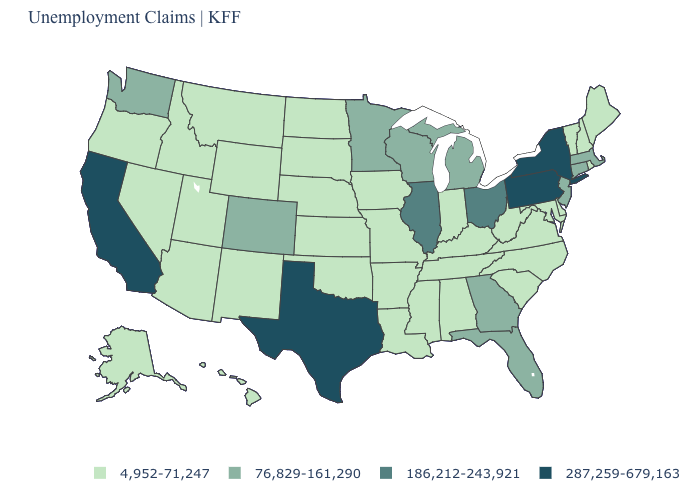What is the value of Missouri?
Keep it brief. 4,952-71,247. What is the value of Utah?
Short answer required. 4,952-71,247. What is the value of Ohio?
Give a very brief answer. 186,212-243,921. Name the states that have a value in the range 4,952-71,247?
Be succinct. Alabama, Alaska, Arizona, Arkansas, Delaware, Hawaii, Idaho, Indiana, Iowa, Kansas, Kentucky, Louisiana, Maine, Maryland, Mississippi, Missouri, Montana, Nebraska, Nevada, New Hampshire, New Mexico, North Carolina, North Dakota, Oklahoma, Oregon, Rhode Island, South Carolina, South Dakota, Tennessee, Utah, Vermont, Virginia, West Virginia, Wyoming. Does Illinois have the lowest value in the MidWest?
Quick response, please. No. Name the states that have a value in the range 287,259-679,163?
Short answer required. California, New York, Pennsylvania, Texas. Name the states that have a value in the range 76,829-161,290?
Concise answer only. Colorado, Connecticut, Florida, Georgia, Massachusetts, Michigan, Minnesota, New Jersey, Washington, Wisconsin. Is the legend a continuous bar?
Be succinct. No. Name the states that have a value in the range 76,829-161,290?
Quick response, please. Colorado, Connecticut, Florida, Georgia, Massachusetts, Michigan, Minnesota, New Jersey, Washington, Wisconsin. Which states have the lowest value in the West?
Concise answer only. Alaska, Arizona, Hawaii, Idaho, Montana, Nevada, New Mexico, Oregon, Utah, Wyoming. Does the first symbol in the legend represent the smallest category?
Give a very brief answer. Yes. Does Michigan have the lowest value in the USA?
Quick response, please. No. What is the value of Indiana?
Short answer required. 4,952-71,247. Among the states that border Tennessee , does Georgia have the lowest value?
Concise answer only. No. What is the highest value in the South ?
Concise answer only. 287,259-679,163. 